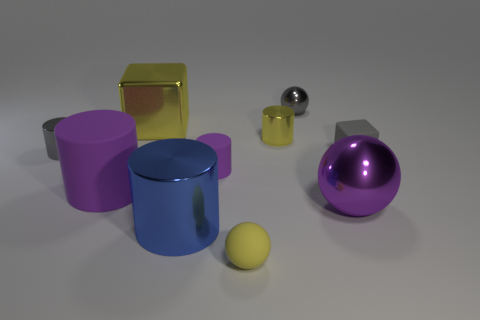What is the material of the gray thing that is the same shape as the purple metallic object?
Make the answer very short. Metal. How many things are shiny objects in front of the big purple cylinder or gray things that are to the left of the tiny gray metal sphere?
Keep it short and to the point. 3. There is a tiny shiny ball; is it the same color as the cube that is in front of the gray metallic cylinder?
Your response must be concise. Yes. There is a big yellow object that is made of the same material as the purple sphere; what is its shape?
Your response must be concise. Cube. What number of large brown blocks are there?
Provide a succinct answer. 0. How many things are rubber objects right of the big yellow shiny object or big purple cylinders?
Offer a very short reply. 4. There is a small cylinder that is in front of the tiny gray cube; is its color the same as the large ball?
Make the answer very short. Yes. What number of other things are the same color as the small rubber block?
Provide a succinct answer. 2. What number of small things are either yellow cubes or brown cubes?
Make the answer very short. 0. Is the number of shiny blocks greater than the number of big purple objects?
Your response must be concise. No. 